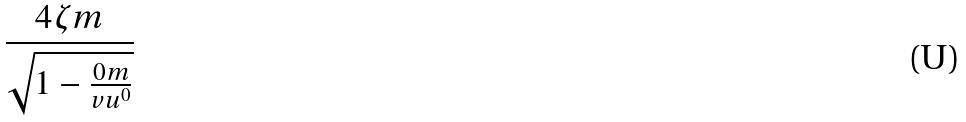Convert formula to latex. <formula><loc_0><loc_0><loc_500><loc_500>\frac { 4 \zeta m } { \sqrt { 1 - \frac { 0 m } { v u ^ { 0 } } } }</formula> 